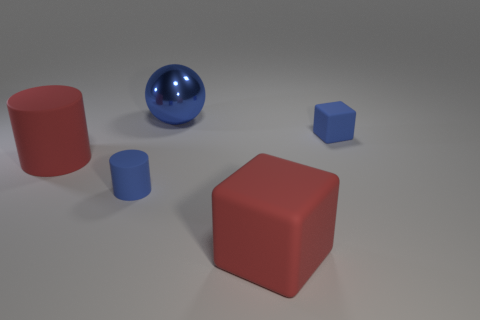Is there a red object that has the same material as the tiny block?
Offer a very short reply. Yes. There is a object that is the same color as the big block; what is its shape?
Offer a terse response. Cylinder. How many blue matte things are there?
Your answer should be very brief. 2. How many spheres are blue rubber things or large shiny things?
Your answer should be compact. 1. There is a matte object that is the same size as the red matte block; what is its color?
Provide a short and direct response. Red. What number of rubber things are both right of the big matte cylinder and to the left of the tiny rubber block?
Your response must be concise. 2. What material is the big blue ball?
Give a very brief answer. Metal. How many things are either rubber blocks or big cyan rubber cylinders?
Your answer should be very brief. 2. Is the size of the blue thing that is left of the big blue metal thing the same as the red rubber thing in front of the tiny blue cylinder?
Offer a very short reply. No. What number of other objects are the same size as the blue cube?
Make the answer very short. 1. 